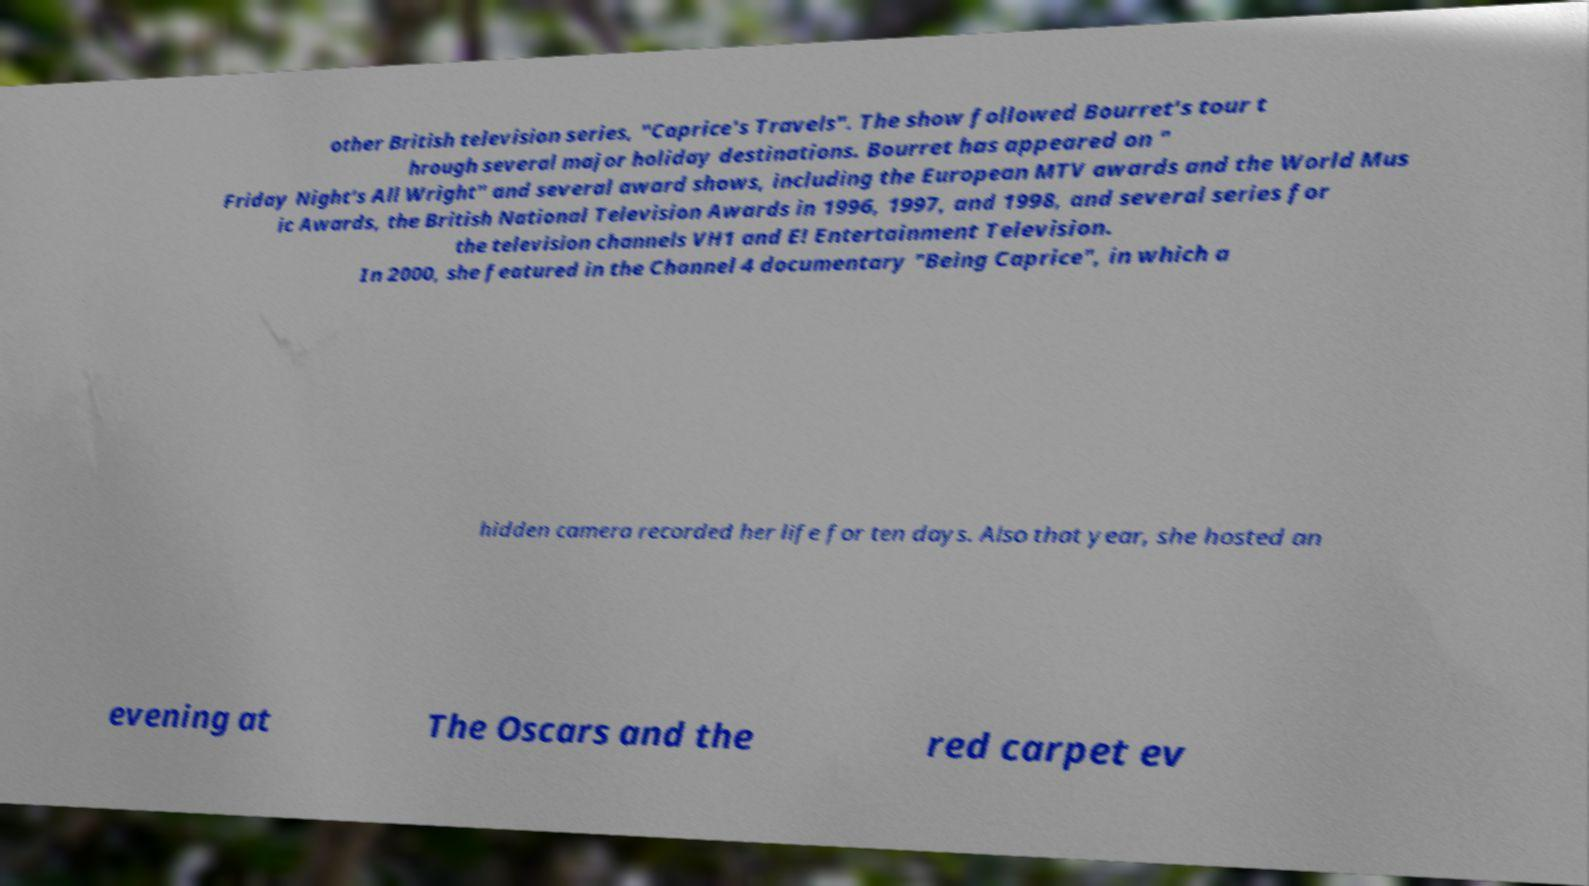For documentation purposes, I need the text within this image transcribed. Could you provide that? other British television series, "Caprice's Travels". The show followed Bourret's tour t hrough several major holiday destinations. Bourret has appeared on " Friday Night's All Wright" and several award shows, including the European MTV awards and the World Mus ic Awards, the British National Television Awards in 1996, 1997, and 1998, and several series for the television channels VH1 and E! Entertainment Television. In 2000, she featured in the Channel 4 documentary "Being Caprice", in which a hidden camera recorded her life for ten days. Also that year, she hosted an evening at The Oscars and the red carpet ev 